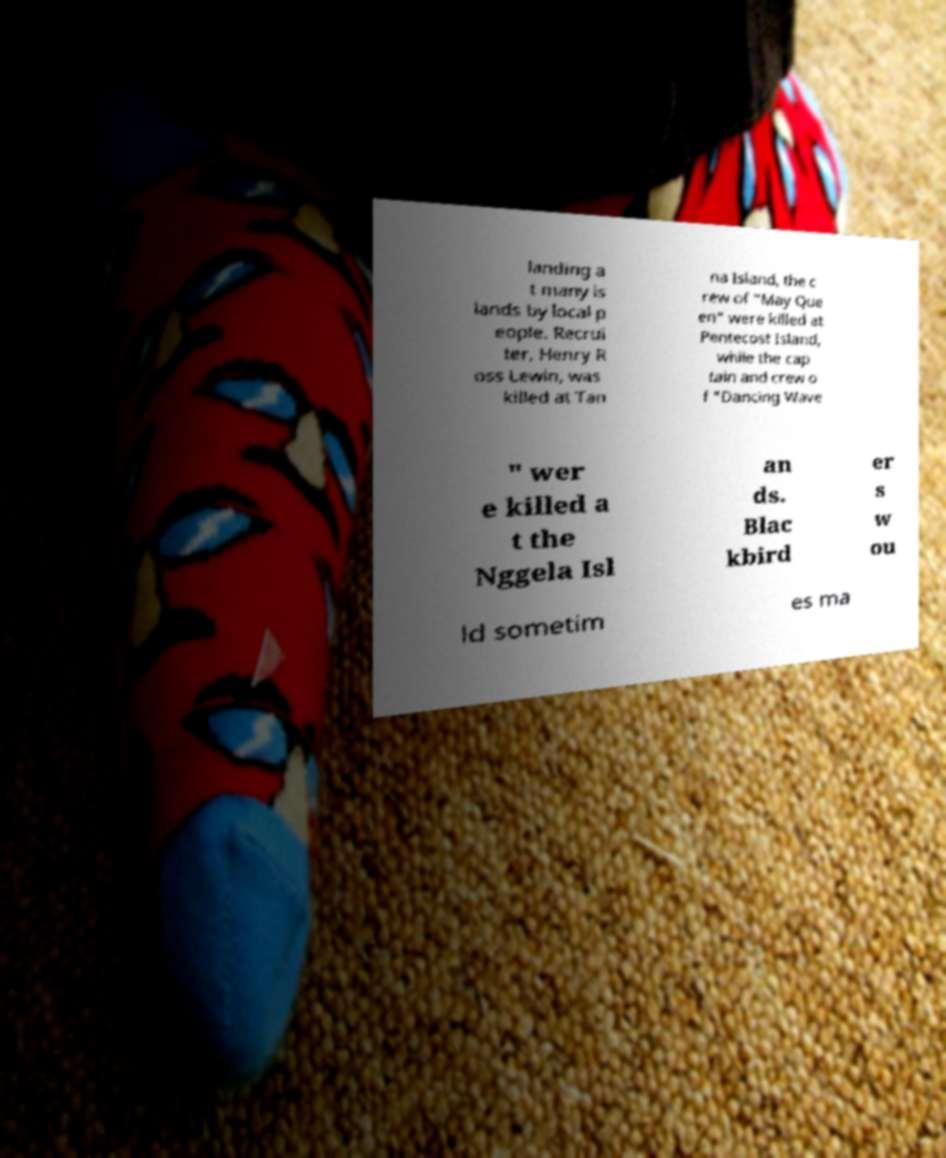I need the written content from this picture converted into text. Can you do that? landing a t many is lands by local p eople. Recrui ter, Henry R oss Lewin, was killed at Tan na Island, the c rew of "May Que en" were killed at Pentecost Island, while the cap tain and crew o f "Dancing Wave " wer e killed a t the Nggela Isl an ds. Blac kbird er s w ou ld sometim es ma 